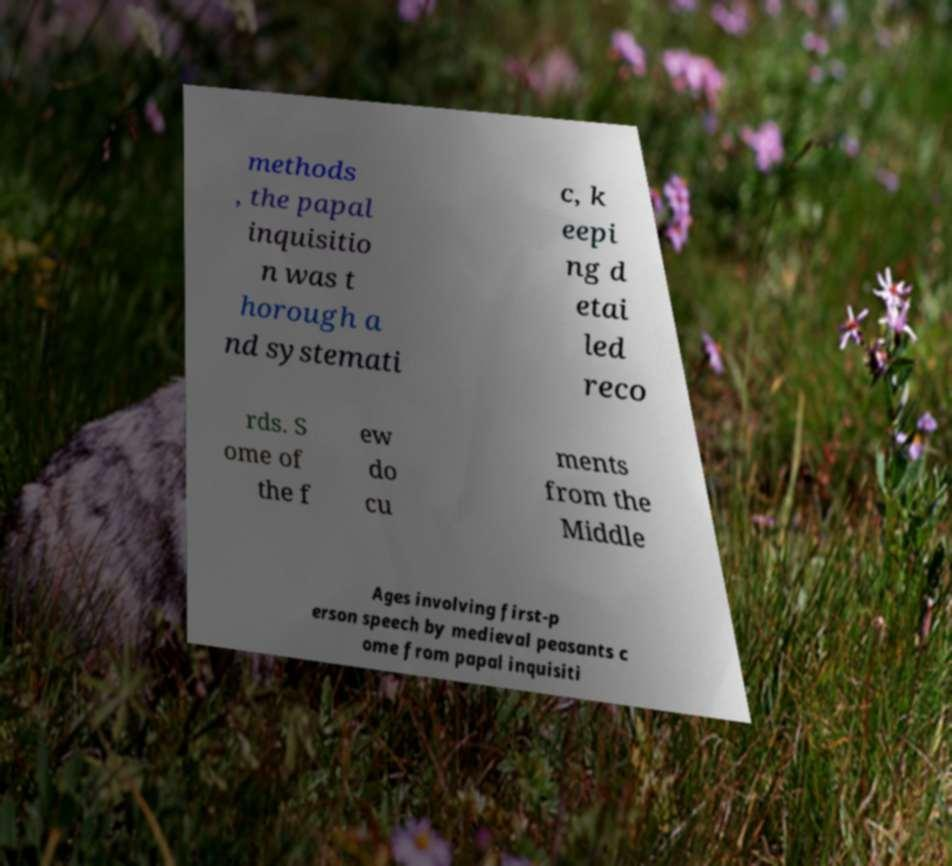Could you assist in decoding the text presented in this image and type it out clearly? methods , the papal inquisitio n was t horough a nd systemati c, k eepi ng d etai led reco rds. S ome of the f ew do cu ments from the Middle Ages involving first-p erson speech by medieval peasants c ome from papal inquisiti 